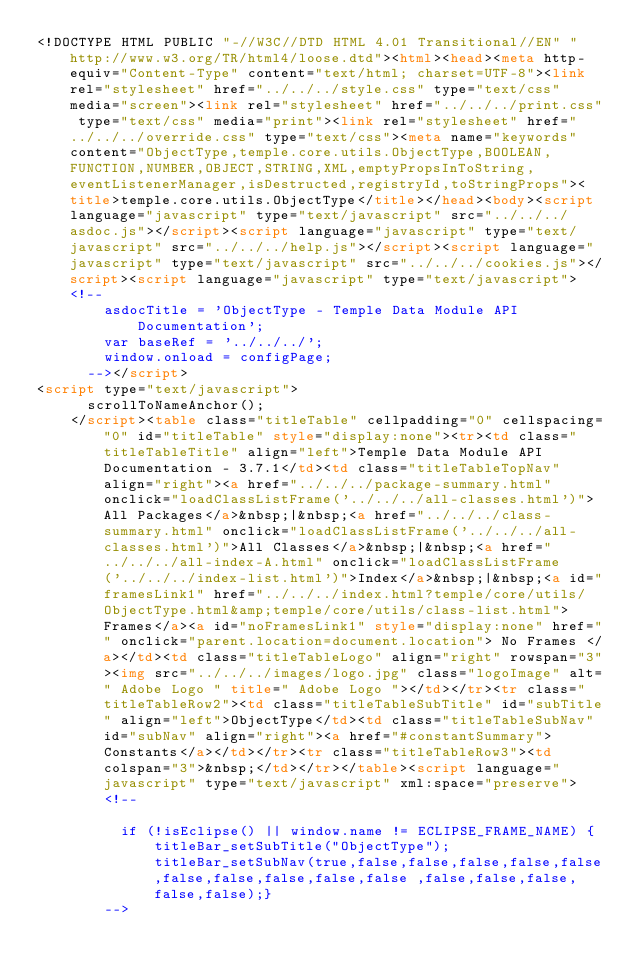Convert code to text. <code><loc_0><loc_0><loc_500><loc_500><_HTML_><!DOCTYPE HTML PUBLIC "-//W3C//DTD HTML 4.01 Transitional//EN" "http://www.w3.org/TR/html4/loose.dtd"><html><head><meta http-equiv="Content-Type" content="text/html; charset=UTF-8"><link rel="stylesheet" href="../../../style.css" type="text/css" media="screen"><link rel="stylesheet" href="../../../print.css" type="text/css" media="print"><link rel="stylesheet" href="../../../override.css" type="text/css"><meta name="keywords" content="ObjectType,temple.core.utils.ObjectType,BOOLEAN,FUNCTION,NUMBER,OBJECT,STRING,XML,emptyPropsInToString,eventListenerManager,isDestructed,registryId,toStringProps"><title>temple.core.utils.ObjectType</title></head><body><script language="javascript" type="text/javascript" src="../../../asdoc.js"></script><script language="javascript" type="text/javascript" src="../../../help.js"></script><script language="javascript" type="text/javascript" src="../../../cookies.js"></script><script language="javascript" type="text/javascript"><!--
				asdocTitle = 'ObjectType - Temple Data Module API Documentation';
				var baseRef = '../../../';
				window.onload = configPage;
			--></script>
<script type="text/javascript">
			scrollToNameAnchor();
		</script><table class="titleTable" cellpadding="0" cellspacing="0" id="titleTable" style="display:none"><tr><td class="titleTableTitle" align="left">Temple Data Module API Documentation - 3.7.1</td><td class="titleTableTopNav" align="right"><a href="../../../package-summary.html" onclick="loadClassListFrame('../../../all-classes.html')">All Packages</a>&nbsp;|&nbsp;<a href="../../../class-summary.html" onclick="loadClassListFrame('../../../all-classes.html')">All Classes</a>&nbsp;|&nbsp;<a href="../../../all-index-A.html" onclick="loadClassListFrame('../../../index-list.html')">Index</a>&nbsp;|&nbsp;<a id="framesLink1" href="../../../index.html?temple/core/utils/ObjectType.html&amp;temple/core/utils/class-list.html">Frames</a><a id="noFramesLink1" style="display:none" href="" onclick="parent.location=document.location"> No Frames </a></td><td class="titleTableLogo" align="right" rowspan="3"><img src="../../../images/logo.jpg" class="logoImage" alt=" Adobe Logo " title=" Adobe Logo "></td></tr><tr class="titleTableRow2"><td class="titleTableSubTitle" id="subTitle" align="left">ObjectType</td><td class="titleTableSubNav" id="subNav" align="right"><a href="#constantSummary">Constants</a></td></tr><tr class="titleTableRow3"><td colspan="3">&nbsp;</td></tr></table><script language="javascript" type="text/javascript" xml:space="preserve">
				<!--
				
					if (!isEclipse() || window.name != ECLIPSE_FRAME_NAME) {titleBar_setSubTitle("ObjectType"); titleBar_setSubNav(true,false,false,false,false,false,false,false,false,false,false	,false,false,false,false,false);}	
				--></code> 